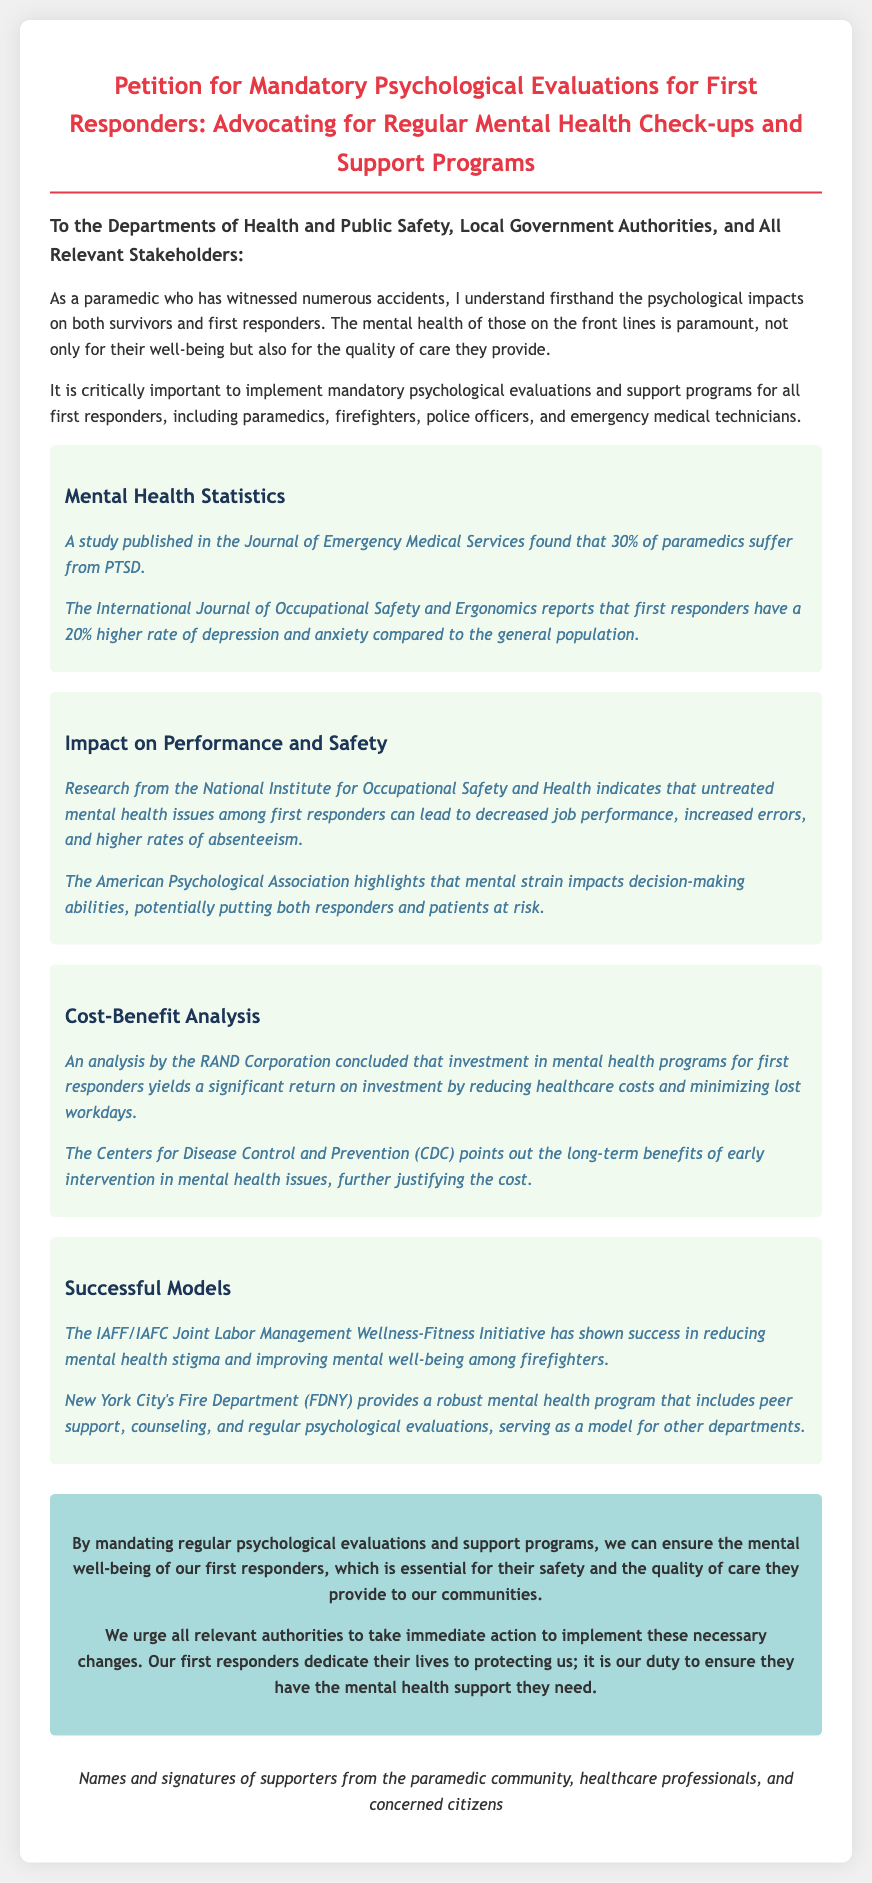What is the main purpose of the petition? The main purpose of the petition is to advocate for mandatory psychological evaluations and support programs for first responders.
Answer: Advocate for mandatory psychological evaluations and support programs for first responders What percentage of paramedics suffer from PTSD according to the document? The document states that a study published in the Journal of Emergency Medical Services found that 30% of paramedics suffer from PTSD.
Answer: 30% Which organization indicates that untreated mental health issues lead to increased errors? The National Institute for Occupational Safety and Health indicates that untreated mental health issues among first responders can lead to increased errors.
Answer: National Institute for Occupational Safety and Health What initiative has shown success in reducing mental health stigma among firefighters? The IAFF/IAFC Joint Labor Management Wellness-Fitness Initiative has shown success in reducing mental health stigma.
Answer: IAFF/IAFC Joint Labor Management Wellness-Fitness Initiative What notable model for mental health programs is mentioned in the document? The document mentions New York City's Fire Department (FDNY) as a notable model for mental health programs.
Answer: New York City's Fire Department (FDNY) What is the main call to action in the conclusion? The main call to action is to urge all relevant authorities to implement necessary changes for mental health support of first responders.
Answer: Urge all relevant authorities to implement necessary changes 